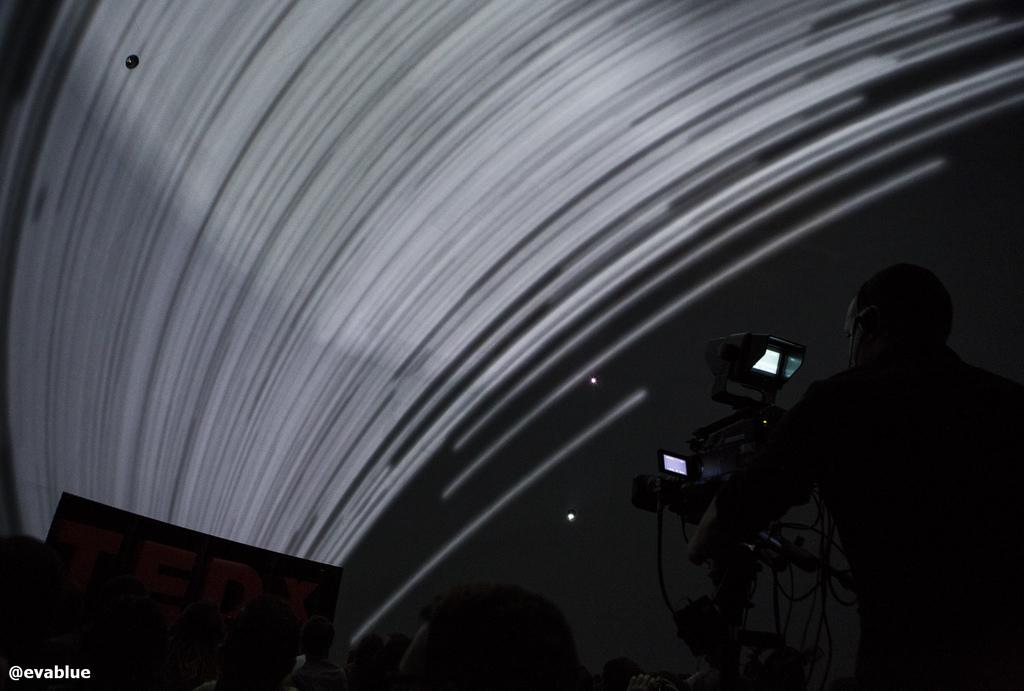Who or what is present in the image? There is a person in the image. What object is used for recording in the image? There is a video camera in the image. What color are the objects on the left side of the image? The objects on the left side of the image are white. What is located at the bottom of the image? There are objects at the bottom of the image. What can be seen in written form in the image? There is text visible in the image. What type of curtain is being used to rub the person's back in the image? There is no curtain present in the image, nor is anyone rubbing the person's back. 